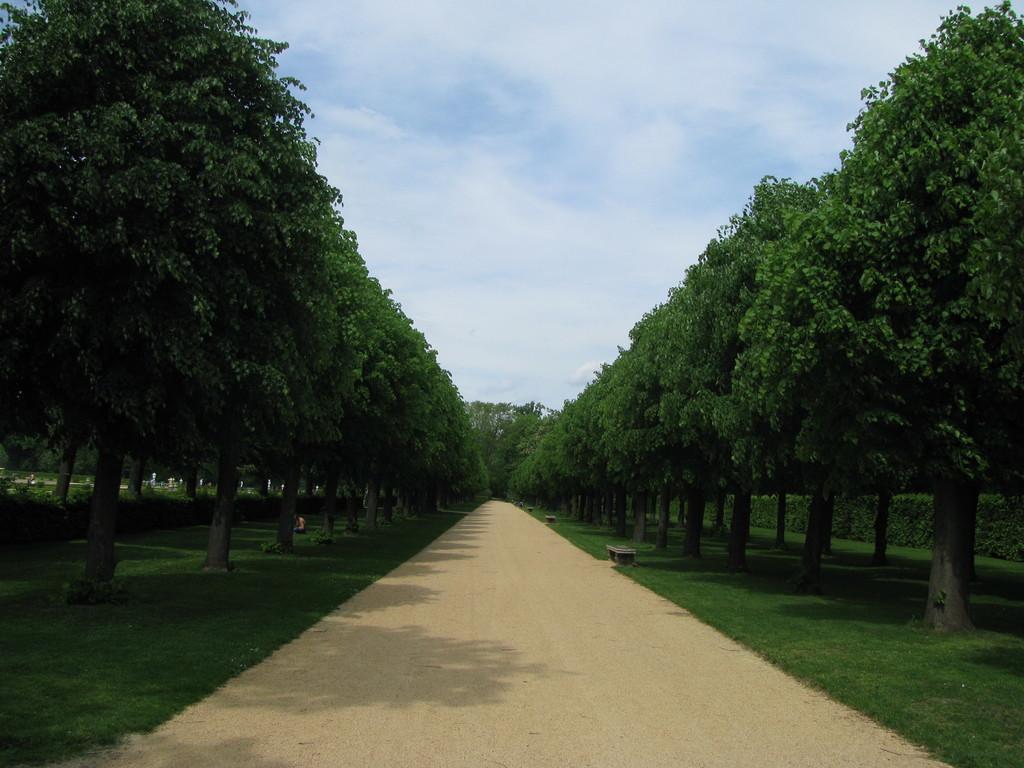In one or two sentences, can you explain what this image depicts? At the bottom this is the way, on either side there are green trees. At the top it is the sky. 